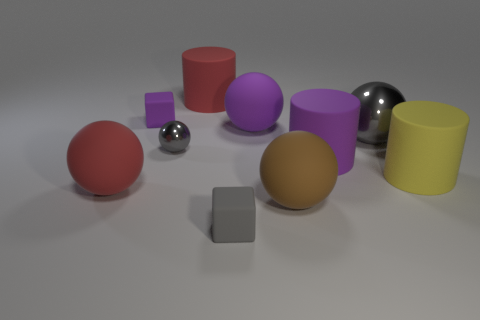Subtract all purple spheres. How many spheres are left? 4 Subtract 1 balls. How many balls are left? 4 Subtract all tiny gray metallic balls. How many balls are left? 4 Subtract all green balls. Subtract all green cylinders. How many balls are left? 5 Subtract all cylinders. How many objects are left? 7 Subtract all cylinders. Subtract all big brown matte spheres. How many objects are left? 6 Add 1 rubber things. How many rubber things are left? 9 Add 7 big shiny objects. How many big shiny objects exist? 8 Subtract 1 purple cylinders. How many objects are left? 9 